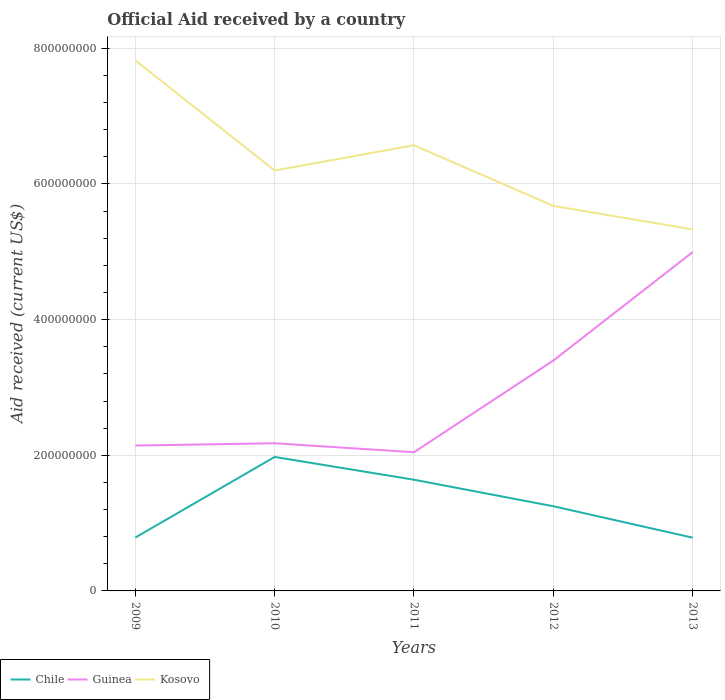How many different coloured lines are there?
Keep it short and to the point. 3. Is the number of lines equal to the number of legend labels?
Your answer should be very brief. Yes. Across all years, what is the maximum net official aid received in Kosovo?
Your response must be concise. 5.33e+08. In which year was the net official aid received in Kosovo maximum?
Provide a succinct answer. 2013. What is the total net official aid received in Guinea in the graph?
Your response must be concise. -3.36e+06. What is the difference between the highest and the second highest net official aid received in Kosovo?
Offer a terse response. 2.49e+08. What is the difference between the highest and the lowest net official aid received in Kosovo?
Your answer should be compact. 2. How many lines are there?
Offer a very short reply. 3. What is the difference between two consecutive major ticks on the Y-axis?
Offer a very short reply. 2.00e+08. Does the graph contain any zero values?
Your answer should be very brief. No. Where does the legend appear in the graph?
Make the answer very short. Bottom left. How are the legend labels stacked?
Keep it short and to the point. Horizontal. What is the title of the graph?
Your response must be concise. Official Aid received by a country. What is the label or title of the X-axis?
Offer a very short reply. Years. What is the label or title of the Y-axis?
Ensure brevity in your answer.  Aid received (current US$). What is the Aid received (current US$) of Chile in 2009?
Give a very brief answer. 7.87e+07. What is the Aid received (current US$) of Guinea in 2009?
Make the answer very short. 2.14e+08. What is the Aid received (current US$) of Kosovo in 2009?
Ensure brevity in your answer.  7.82e+08. What is the Aid received (current US$) in Chile in 2010?
Provide a succinct answer. 1.98e+08. What is the Aid received (current US$) of Guinea in 2010?
Your answer should be compact. 2.18e+08. What is the Aid received (current US$) of Kosovo in 2010?
Make the answer very short. 6.20e+08. What is the Aid received (current US$) in Chile in 2011?
Offer a very short reply. 1.64e+08. What is the Aid received (current US$) in Guinea in 2011?
Ensure brevity in your answer.  2.04e+08. What is the Aid received (current US$) in Kosovo in 2011?
Keep it short and to the point. 6.57e+08. What is the Aid received (current US$) in Chile in 2012?
Make the answer very short. 1.25e+08. What is the Aid received (current US$) in Guinea in 2012?
Your response must be concise. 3.40e+08. What is the Aid received (current US$) of Kosovo in 2012?
Your response must be concise. 5.68e+08. What is the Aid received (current US$) in Chile in 2013?
Keep it short and to the point. 7.85e+07. What is the Aid received (current US$) of Guinea in 2013?
Ensure brevity in your answer.  5.00e+08. What is the Aid received (current US$) of Kosovo in 2013?
Provide a succinct answer. 5.33e+08. Across all years, what is the maximum Aid received (current US$) of Chile?
Your answer should be compact. 1.98e+08. Across all years, what is the maximum Aid received (current US$) in Guinea?
Your response must be concise. 5.00e+08. Across all years, what is the maximum Aid received (current US$) of Kosovo?
Make the answer very short. 7.82e+08. Across all years, what is the minimum Aid received (current US$) in Chile?
Provide a succinct answer. 7.85e+07. Across all years, what is the minimum Aid received (current US$) of Guinea?
Give a very brief answer. 2.04e+08. Across all years, what is the minimum Aid received (current US$) of Kosovo?
Keep it short and to the point. 5.33e+08. What is the total Aid received (current US$) of Chile in the graph?
Offer a terse response. 6.44e+08. What is the total Aid received (current US$) in Guinea in the graph?
Offer a very short reply. 1.48e+09. What is the total Aid received (current US$) in Kosovo in the graph?
Make the answer very short. 3.16e+09. What is the difference between the Aid received (current US$) of Chile in 2009 and that in 2010?
Provide a short and direct response. -1.19e+08. What is the difference between the Aid received (current US$) of Guinea in 2009 and that in 2010?
Make the answer very short. -3.36e+06. What is the difference between the Aid received (current US$) in Kosovo in 2009 and that in 2010?
Your response must be concise. 1.62e+08. What is the difference between the Aid received (current US$) in Chile in 2009 and that in 2011?
Ensure brevity in your answer.  -8.52e+07. What is the difference between the Aid received (current US$) of Guinea in 2009 and that in 2011?
Your answer should be very brief. 9.85e+06. What is the difference between the Aid received (current US$) of Kosovo in 2009 and that in 2011?
Provide a succinct answer. 1.25e+08. What is the difference between the Aid received (current US$) in Chile in 2009 and that in 2012?
Keep it short and to the point. -4.61e+07. What is the difference between the Aid received (current US$) of Guinea in 2009 and that in 2012?
Offer a terse response. -1.25e+08. What is the difference between the Aid received (current US$) of Kosovo in 2009 and that in 2012?
Your answer should be compact. 2.14e+08. What is the difference between the Aid received (current US$) of Guinea in 2009 and that in 2013?
Offer a terse response. -2.85e+08. What is the difference between the Aid received (current US$) of Kosovo in 2009 and that in 2013?
Make the answer very short. 2.49e+08. What is the difference between the Aid received (current US$) of Chile in 2010 and that in 2011?
Your response must be concise. 3.36e+07. What is the difference between the Aid received (current US$) in Guinea in 2010 and that in 2011?
Your answer should be compact. 1.32e+07. What is the difference between the Aid received (current US$) of Kosovo in 2010 and that in 2011?
Your response must be concise. -3.72e+07. What is the difference between the Aid received (current US$) of Chile in 2010 and that in 2012?
Your answer should be compact. 7.27e+07. What is the difference between the Aid received (current US$) of Guinea in 2010 and that in 2012?
Offer a terse response. -1.22e+08. What is the difference between the Aid received (current US$) in Kosovo in 2010 and that in 2012?
Your response must be concise. 5.22e+07. What is the difference between the Aid received (current US$) of Chile in 2010 and that in 2013?
Your response must be concise. 1.19e+08. What is the difference between the Aid received (current US$) in Guinea in 2010 and that in 2013?
Your answer should be compact. -2.82e+08. What is the difference between the Aid received (current US$) in Kosovo in 2010 and that in 2013?
Ensure brevity in your answer.  8.68e+07. What is the difference between the Aid received (current US$) of Chile in 2011 and that in 2012?
Your answer should be very brief. 3.91e+07. What is the difference between the Aid received (current US$) in Guinea in 2011 and that in 2012?
Keep it short and to the point. -1.35e+08. What is the difference between the Aid received (current US$) of Kosovo in 2011 and that in 2012?
Give a very brief answer. 8.94e+07. What is the difference between the Aid received (current US$) of Chile in 2011 and that in 2013?
Your answer should be compact. 8.54e+07. What is the difference between the Aid received (current US$) in Guinea in 2011 and that in 2013?
Make the answer very short. -2.95e+08. What is the difference between the Aid received (current US$) of Kosovo in 2011 and that in 2013?
Your response must be concise. 1.24e+08. What is the difference between the Aid received (current US$) of Chile in 2012 and that in 2013?
Keep it short and to the point. 4.63e+07. What is the difference between the Aid received (current US$) in Guinea in 2012 and that in 2013?
Ensure brevity in your answer.  -1.60e+08. What is the difference between the Aid received (current US$) of Kosovo in 2012 and that in 2013?
Provide a short and direct response. 3.46e+07. What is the difference between the Aid received (current US$) of Chile in 2009 and the Aid received (current US$) of Guinea in 2010?
Your answer should be compact. -1.39e+08. What is the difference between the Aid received (current US$) of Chile in 2009 and the Aid received (current US$) of Kosovo in 2010?
Provide a succinct answer. -5.41e+08. What is the difference between the Aid received (current US$) of Guinea in 2009 and the Aid received (current US$) of Kosovo in 2010?
Give a very brief answer. -4.06e+08. What is the difference between the Aid received (current US$) in Chile in 2009 and the Aid received (current US$) in Guinea in 2011?
Your answer should be compact. -1.26e+08. What is the difference between the Aid received (current US$) in Chile in 2009 and the Aid received (current US$) in Kosovo in 2011?
Your answer should be compact. -5.78e+08. What is the difference between the Aid received (current US$) in Guinea in 2009 and the Aid received (current US$) in Kosovo in 2011?
Offer a terse response. -4.43e+08. What is the difference between the Aid received (current US$) of Chile in 2009 and the Aid received (current US$) of Guinea in 2012?
Make the answer very short. -2.61e+08. What is the difference between the Aid received (current US$) of Chile in 2009 and the Aid received (current US$) of Kosovo in 2012?
Give a very brief answer. -4.89e+08. What is the difference between the Aid received (current US$) in Guinea in 2009 and the Aid received (current US$) in Kosovo in 2012?
Your answer should be very brief. -3.53e+08. What is the difference between the Aid received (current US$) in Chile in 2009 and the Aid received (current US$) in Guinea in 2013?
Provide a short and direct response. -4.21e+08. What is the difference between the Aid received (current US$) in Chile in 2009 and the Aid received (current US$) in Kosovo in 2013?
Make the answer very short. -4.54e+08. What is the difference between the Aid received (current US$) in Guinea in 2009 and the Aid received (current US$) in Kosovo in 2013?
Keep it short and to the point. -3.19e+08. What is the difference between the Aid received (current US$) of Chile in 2010 and the Aid received (current US$) of Guinea in 2011?
Your response must be concise. -6.97e+06. What is the difference between the Aid received (current US$) of Chile in 2010 and the Aid received (current US$) of Kosovo in 2011?
Ensure brevity in your answer.  -4.60e+08. What is the difference between the Aid received (current US$) of Guinea in 2010 and the Aid received (current US$) of Kosovo in 2011?
Provide a short and direct response. -4.39e+08. What is the difference between the Aid received (current US$) of Chile in 2010 and the Aid received (current US$) of Guinea in 2012?
Give a very brief answer. -1.42e+08. What is the difference between the Aid received (current US$) of Chile in 2010 and the Aid received (current US$) of Kosovo in 2012?
Give a very brief answer. -3.70e+08. What is the difference between the Aid received (current US$) of Guinea in 2010 and the Aid received (current US$) of Kosovo in 2012?
Provide a short and direct response. -3.50e+08. What is the difference between the Aid received (current US$) of Chile in 2010 and the Aid received (current US$) of Guinea in 2013?
Give a very brief answer. -3.02e+08. What is the difference between the Aid received (current US$) of Chile in 2010 and the Aid received (current US$) of Kosovo in 2013?
Offer a very short reply. -3.36e+08. What is the difference between the Aid received (current US$) of Guinea in 2010 and the Aid received (current US$) of Kosovo in 2013?
Provide a succinct answer. -3.15e+08. What is the difference between the Aid received (current US$) of Chile in 2011 and the Aid received (current US$) of Guinea in 2012?
Your answer should be very brief. -1.76e+08. What is the difference between the Aid received (current US$) of Chile in 2011 and the Aid received (current US$) of Kosovo in 2012?
Offer a terse response. -4.04e+08. What is the difference between the Aid received (current US$) in Guinea in 2011 and the Aid received (current US$) in Kosovo in 2012?
Make the answer very short. -3.63e+08. What is the difference between the Aid received (current US$) of Chile in 2011 and the Aid received (current US$) of Guinea in 2013?
Provide a succinct answer. -3.36e+08. What is the difference between the Aid received (current US$) of Chile in 2011 and the Aid received (current US$) of Kosovo in 2013?
Give a very brief answer. -3.69e+08. What is the difference between the Aid received (current US$) in Guinea in 2011 and the Aid received (current US$) in Kosovo in 2013?
Offer a terse response. -3.29e+08. What is the difference between the Aid received (current US$) in Chile in 2012 and the Aid received (current US$) in Guinea in 2013?
Your response must be concise. -3.75e+08. What is the difference between the Aid received (current US$) in Chile in 2012 and the Aid received (current US$) in Kosovo in 2013?
Offer a very short reply. -4.08e+08. What is the difference between the Aid received (current US$) of Guinea in 2012 and the Aid received (current US$) of Kosovo in 2013?
Provide a succinct answer. -1.93e+08. What is the average Aid received (current US$) in Chile per year?
Ensure brevity in your answer.  1.29e+08. What is the average Aid received (current US$) of Guinea per year?
Offer a very short reply. 2.95e+08. What is the average Aid received (current US$) of Kosovo per year?
Your answer should be very brief. 6.32e+08. In the year 2009, what is the difference between the Aid received (current US$) in Chile and Aid received (current US$) in Guinea?
Provide a succinct answer. -1.36e+08. In the year 2009, what is the difference between the Aid received (current US$) of Chile and Aid received (current US$) of Kosovo?
Provide a short and direct response. -7.03e+08. In the year 2009, what is the difference between the Aid received (current US$) of Guinea and Aid received (current US$) of Kosovo?
Provide a succinct answer. -5.68e+08. In the year 2010, what is the difference between the Aid received (current US$) in Chile and Aid received (current US$) in Guinea?
Keep it short and to the point. -2.02e+07. In the year 2010, what is the difference between the Aid received (current US$) in Chile and Aid received (current US$) in Kosovo?
Make the answer very short. -4.22e+08. In the year 2010, what is the difference between the Aid received (current US$) of Guinea and Aid received (current US$) of Kosovo?
Provide a short and direct response. -4.02e+08. In the year 2011, what is the difference between the Aid received (current US$) of Chile and Aid received (current US$) of Guinea?
Offer a terse response. -4.05e+07. In the year 2011, what is the difference between the Aid received (current US$) of Chile and Aid received (current US$) of Kosovo?
Ensure brevity in your answer.  -4.93e+08. In the year 2011, what is the difference between the Aid received (current US$) of Guinea and Aid received (current US$) of Kosovo?
Provide a short and direct response. -4.53e+08. In the year 2012, what is the difference between the Aid received (current US$) in Chile and Aid received (current US$) in Guinea?
Your response must be concise. -2.15e+08. In the year 2012, what is the difference between the Aid received (current US$) in Chile and Aid received (current US$) in Kosovo?
Your answer should be very brief. -4.43e+08. In the year 2012, what is the difference between the Aid received (current US$) of Guinea and Aid received (current US$) of Kosovo?
Your response must be concise. -2.28e+08. In the year 2013, what is the difference between the Aid received (current US$) in Chile and Aid received (current US$) in Guinea?
Ensure brevity in your answer.  -4.21e+08. In the year 2013, what is the difference between the Aid received (current US$) of Chile and Aid received (current US$) of Kosovo?
Your response must be concise. -4.55e+08. In the year 2013, what is the difference between the Aid received (current US$) in Guinea and Aid received (current US$) in Kosovo?
Provide a succinct answer. -3.35e+07. What is the ratio of the Aid received (current US$) of Chile in 2009 to that in 2010?
Your answer should be compact. 0.4. What is the ratio of the Aid received (current US$) of Guinea in 2009 to that in 2010?
Make the answer very short. 0.98. What is the ratio of the Aid received (current US$) in Kosovo in 2009 to that in 2010?
Make the answer very short. 1.26. What is the ratio of the Aid received (current US$) in Chile in 2009 to that in 2011?
Your answer should be very brief. 0.48. What is the ratio of the Aid received (current US$) of Guinea in 2009 to that in 2011?
Ensure brevity in your answer.  1.05. What is the ratio of the Aid received (current US$) of Kosovo in 2009 to that in 2011?
Provide a succinct answer. 1.19. What is the ratio of the Aid received (current US$) of Chile in 2009 to that in 2012?
Provide a short and direct response. 0.63. What is the ratio of the Aid received (current US$) of Guinea in 2009 to that in 2012?
Your answer should be compact. 0.63. What is the ratio of the Aid received (current US$) in Kosovo in 2009 to that in 2012?
Your answer should be compact. 1.38. What is the ratio of the Aid received (current US$) of Chile in 2009 to that in 2013?
Your response must be concise. 1. What is the ratio of the Aid received (current US$) of Guinea in 2009 to that in 2013?
Make the answer very short. 0.43. What is the ratio of the Aid received (current US$) in Kosovo in 2009 to that in 2013?
Make the answer very short. 1.47. What is the ratio of the Aid received (current US$) of Chile in 2010 to that in 2011?
Give a very brief answer. 1.2. What is the ratio of the Aid received (current US$) in Guinea in 2010 to that in 2011?
Your answer should be compact. 1.06. What is the ratio of the Aid received (current US$) of Kosovo in 2010 to that in 2011?
Provide a short and direct response. 0.94. What is the ratio of the Aid received (current US$) of Chile in 2010 to that in 2012?
Provide a succinct answer. 1.58. What is the ratio of the Aid received (current US$) in Guinea in 2010 to that in 2012?
Your answer should be very brief. 0.64. What is the ratio of the Aid received (current US$) of Kosovo in 2010 to that in 2012?
Provide a succinct answer. 1.09. What is the ratio of the Aid received (current US$) in Chile in 2010 to that in 2013?
Offer a terse response. 2.52. What is the ratio of the Aid received (current US$) in Guinea in 2010 to that in 2013?
Make the answer very short. 0.44. What is the ratio of the Aid received (current US$) of Kosovo in 2010 to that in 2013?
Your answer should be compact. 1.16. What is the ratio of the Aid received (current US$) of Chile in 2011 to that in 2012?
Your answer should be very brief. 1.31. What is the ratio of the Aid received (current US$) of Guinea in 2011 to that in 2012?
Offer a very short reply. 0.6. What is the ratio of the Aid received (current US$) of Kosovo in 2011 to that in 2012?
Your answer should be compact. 1.16. What is the ratio of the Aid received (current US$) in Chile in 2011 to that in 2013?
Your answer should be very brief. 2.09. What is the ratio of the Aid received (current US$) of Guinea in 2011 to that in 2013?
Make the answer very short. 0.41. What is the ratio of the Aid received (current US$) in Kosovo in 2011 to that in 2013?
Ensure brevity in your answer.  1.23. What is the ratio of the Aid received (current US$) of Chile in 2012 to that in 2013?
Make the answer very short. 1.59. What is the ratio of the Aid received (current US$) in Guinea in 2012 to that in 2013?
Your answer should be compact. 0.68. What is the ratio of the Aid received (current US$) of Kosovo in 2012 to that in 2013?
Your answer should be compact. 1.06. What is the difference between the highest and the second highest Aid received (current US$) in Chile?
Ensure brevity in your answer.  3.36e+07. What is the difference between the highest and the second highest Aid received (current US$) of Guinea?
Give a very brief answer. 1.60e+08. What is the difference between the highest and the second highest Aid received (current US$) of Kosovo?
Make the answer very short. 1.25e+08. What is the difference between the highest and the lowest Aid received (current US$) in Chile?
Provide a short and direct response. 1.19e+08. What is the difference between the highest and the lowest Aid received (current US$) of Guinea?
Your answer should be very brief. 2.95e+08. What is the difference between the highest and the lowest Aid received (current US$) of Kosovo?
Give a very brief answer. 2.49e+08. 